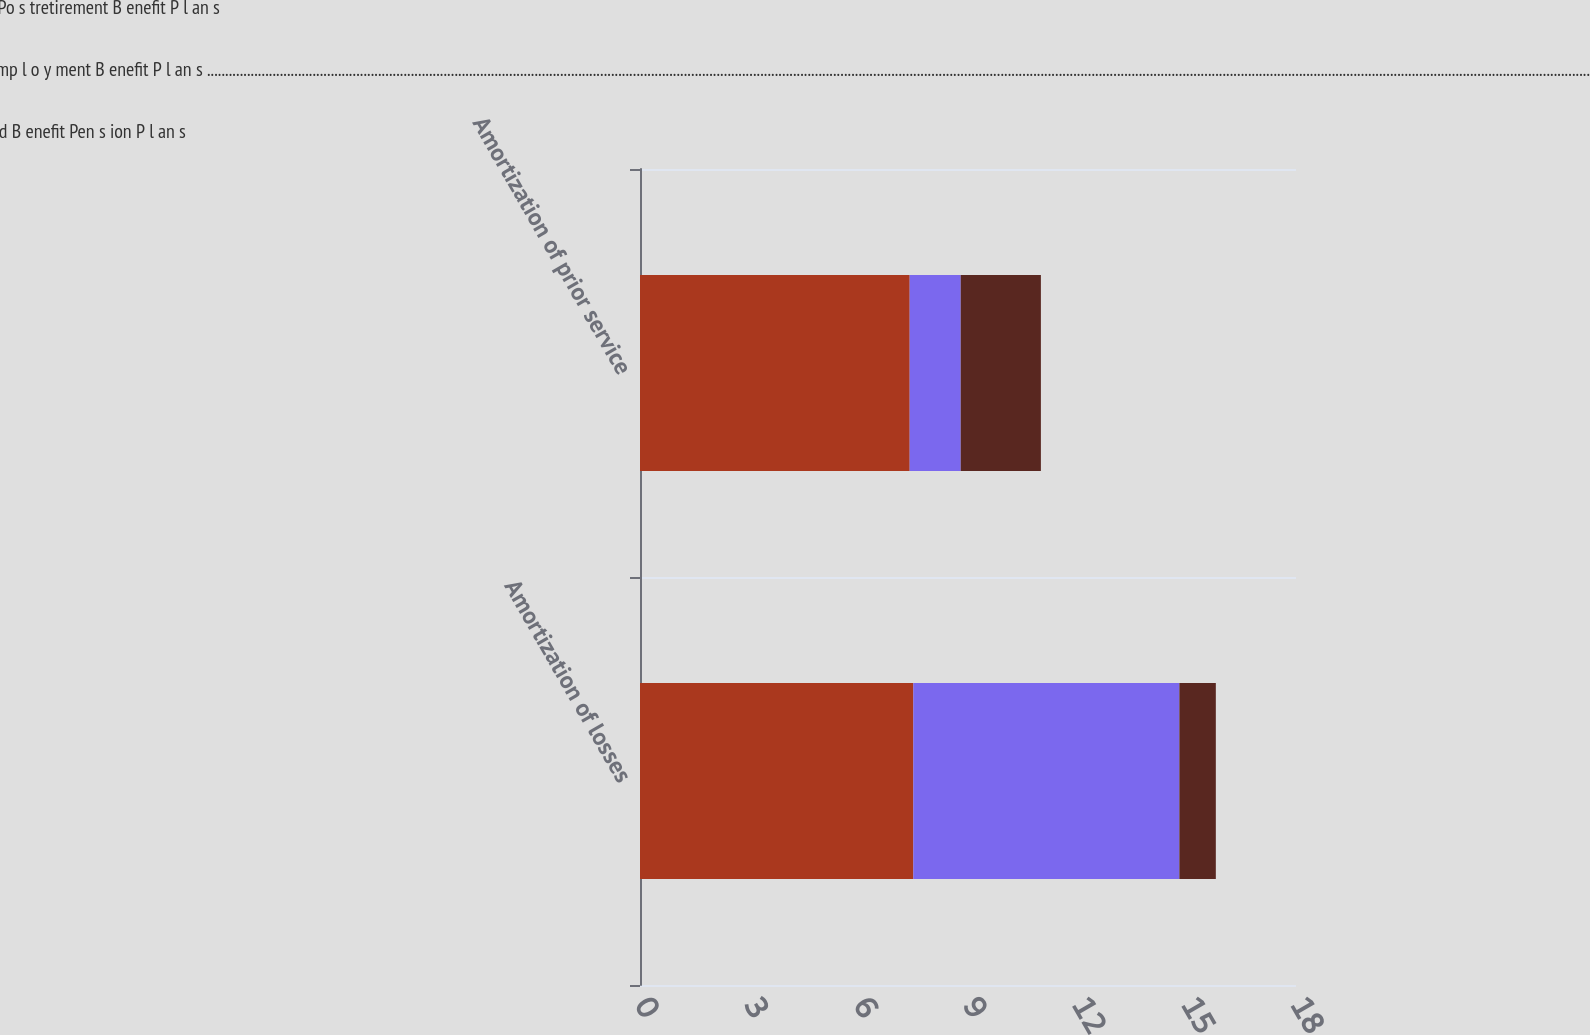Convert chart to OTSL. <chart><loc_0><loc_0><loc_500><loc_500><stacked_bar_chart><ecel><fcel>Amortization of losses<fcel>Amortization of prior service<nl><fcel>O ther Po s tretirement B enefit P l an s<fcel>7.5<fcel>7.4<nl><fcel>Po s temp l o y ment B enefit P l an s ............................................................................................................................................................................................................................................................................................................................................................................................<fcel>7.3<fcel>1.4<nl><fcel>D efined B enefit Pen s ion P l an s<fcel>1<fcel>2.2<nl></chart> 